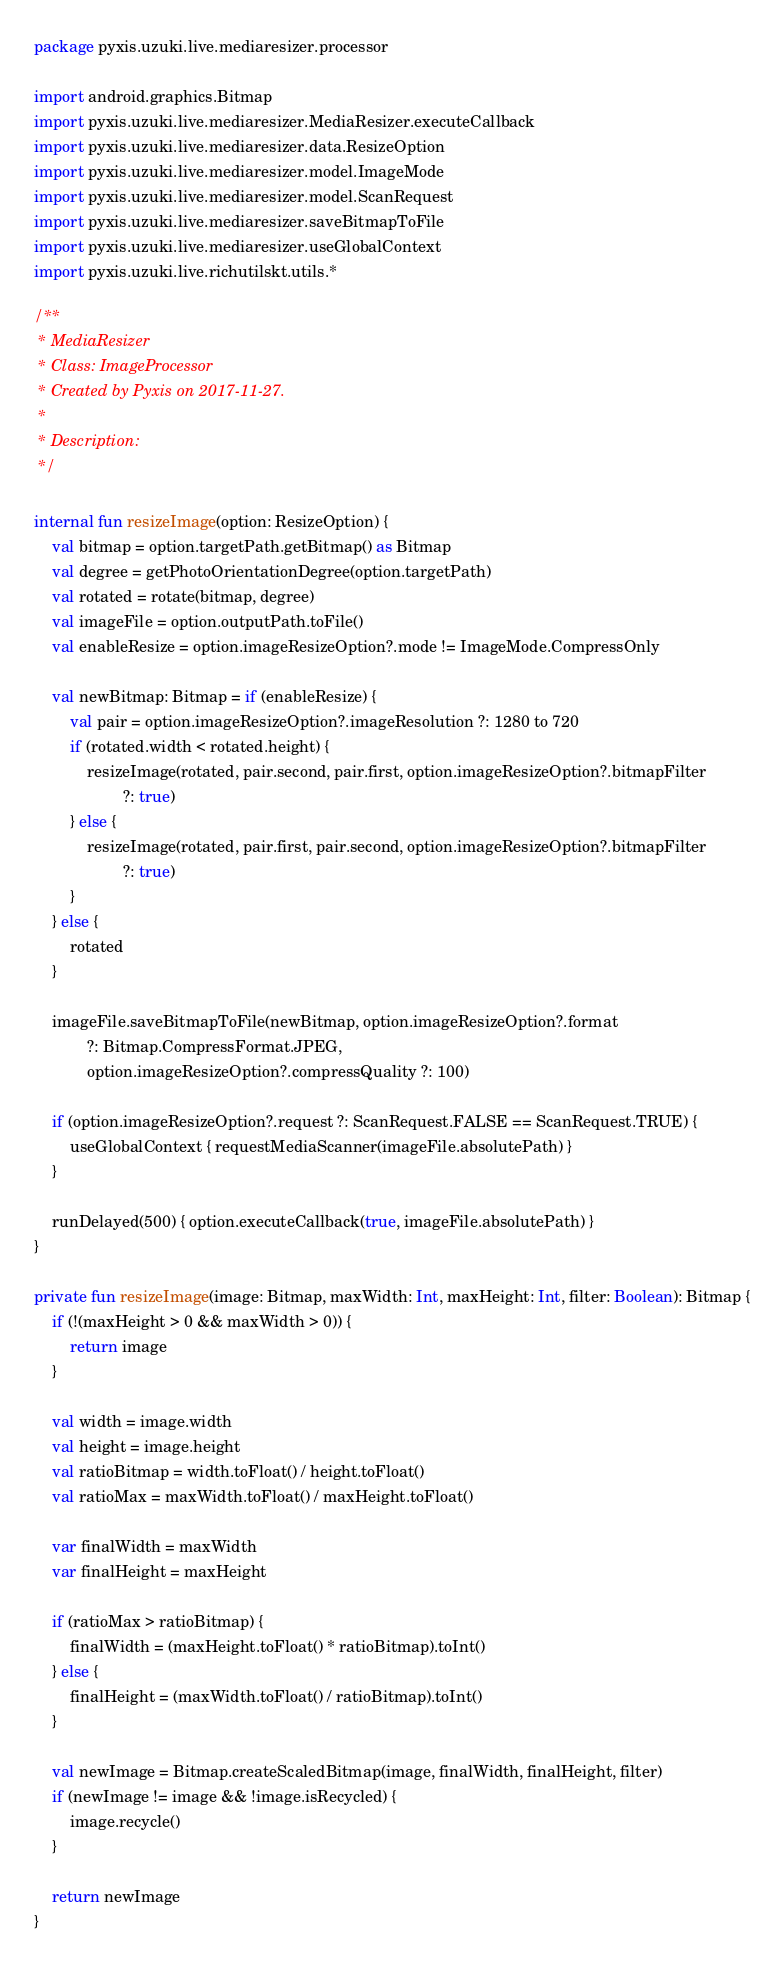Convert code to text. <code><loc_0><loc_0><loc_500><loc_500><_Kotlin_>package pyxis.uzuki.live.mediaresizer.processor

import android.graphics.Bitmap
import pyxis.uzuki.live.mediaresizer.MediaResizer.executeCallback
import pyxis.uzuki.live.mediaresizer.data.ResizeOption
import pyxis.uzuki.live.mediaresizer.model.ImageMode
import pyxis.uzuki.live.mediaresizer.model.ScanRequest
import pyxis.uzuki.live.mediaresizer.saveBitmapToFile
import pyxis.uzuki.live.mediaresizer.useGlobalContext
import pyxis.uzuki.live.richutilskt.utils.*

/**
 * MediaResizer
 * Class: ImageProcessor
 * Created by Pyxis on 2017-11-27.
 *
 * Description:
 */

internal fun resizeImage(option: ResizeOption) {
    val bitmap = option.targetPath.getBitmap() as Bitmap
    val degree = getPhotoOrientationDegree(option.targetPath)
    val rotated = rotate(bitmap, degree)
    val imageFile = option.outputPath.toFile()
    val enableResize = option.imageResizeOption?.mode != ImageMode.CompressOnly

    val newBitmap: Bitmap = if (enableResize) {
        val pair = option.imageResizeOption?.imageResolution ?: 1280 to 720
        if (rotated.width < rotated.height) {
            resizeImage(rotated, pair.second, pair.first, option.imageResizeOption?.bitmapFilter
                    ?: true)
        } else {
            resizeImage(rotated, pair.first, pair.second, option.imageResizeOption?.bitmapFilter
                    ?: true)
        }
    } else {
        rotated
    }

    imageFile.saveBitmapToFile(newBitmap, option.imageResizeOption?.format
            ?: Bitmap.CompressFormat.JPEG,
            option.imageResizeOption?.compressQuality ?: 100)

    if (option.imageResizeOption?.request ?: ScanRequest.FALSE == ScanRequest.TRUE) {
        useGlobalContext { requestMediaScanner(imageFile.absolutePath) }
    }

    runDelayed(500) { option.executeCallback(true, imageFile.absolutePath) }
}

private fun resizeImage(image: Bitmap, maxWidth: Int, maxHeight: Int, filter: Boolean): Bitmap {
    if (!(maxHeight > 0 && maxWidth > 0)) {
        return image
    }

    val width = image.width
    val height = image.height
    val ratioBitmap = width.toFloat() / height.toFloat()
    val ratioMax = maxWidth.toFloat() / maxHeight.toFloat()

    var finalWidth = maxWidth
    var finalHeight = maxHeight

    if (ratioMax > ratioBitmap) {
        finalWidth = (maxHeight.toFloat() * ratioBitmap).toInt()
    } else {
        finalHeight = (maxWidth.toFloat() / ratioBitmap).toInt()
    }

    val newImage = Bitmap.createScaledBitmap(image, finalWidth, finalHeight, filter)
    if (newImage != image && !image.isRecycled) {
        image.recycle()
    }

    return newImage
}</code> 